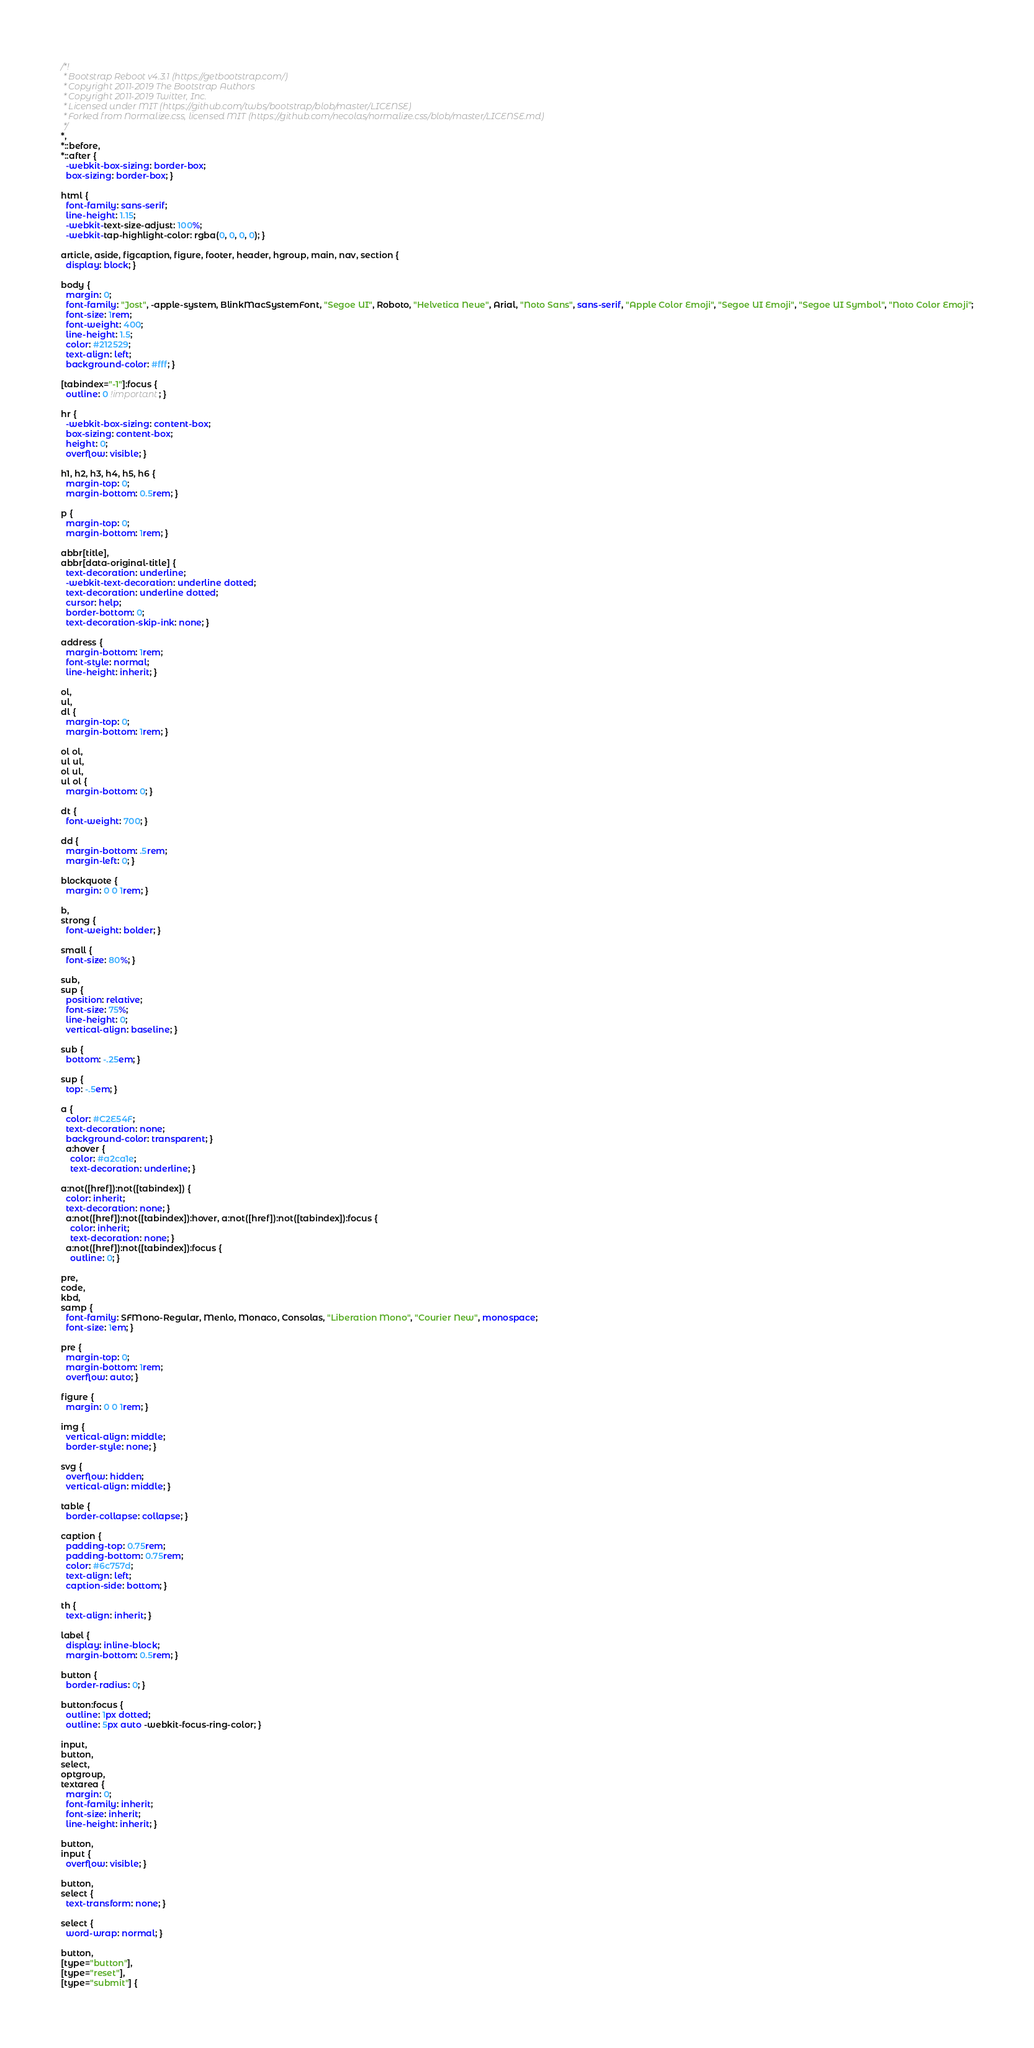<code> <loc_0><loc_0><loc_500><loc_500><_CSS_>/*!
 * Bootstrap Reboot v4.3.1 (https://getbootstrap.com/)
 * Copyright 2011-2019 The Bootstrap Authors
 * Copyright 2011-2019 Twitter, Inc.
 * Licensed under MIT (https://github.com/twbs/bootstrap/blob/master/LICENSE)
 * Forked from Normalize.css, licensed MIT (https://github.com/necolas/normalize.css/blob/master/LICENSE.md)
 */
*,
*::before,
*::after {
  -webkit-box-sizing: border-box;
  box-sizing: border-box; }

html {
  font-family: sans-serif;
  line-height: 1.15;
  -webkit-text-size-adjust: 100%;
  -webkit-tap-highlight-color: rgba(0, 0, 0, 0); }

article, aside, figcaption, figure, footer, header, hgroup, main, nav, section {
  display: block; }

body {
  margin: 0;
  font-family: "Jost", -apple-system, BlinkMacSystemFont, "Segoe UI", Roboto, "Helvetica Neue", Arial, "Noto Sans", sans-serif, "Apple Color Emoji", "Segoe UI Emoji", "Segoe UI Symbol", "Noto Color Emoji";
  font-size: 1rem;
  font-weight: 400;
  line-height: 1.5;
  color: #212529;
  text-align: left;
  background-color: #fff; }

[tabindex="-1"]:focus {
  outline: 0 !important; }

hr {
  -webkit-box-sizing: content-box;
  box-sizing: content-box;
  height: 0;
  overflow: visible; }

h1, h2, h3, h4, h5, h6 {
  margin-top: 0;
  margin-bottom: 0.5rem; }

p {
  margin-top: 0;
  margin-bottom: 1rem; }

abbr[title],
abbr[data-original-title] {
  text-decoration: underline;
  -webkit-text-decoration: underline dotted;
  text-decoration: underline dotted;
  cursor: help;
  border-bottom: 0;
  text-decoration-skip-ink: none; }

address {
  margin-bottom: 1rem;
  font-style: normal;
  line-height: inherit; }

ol,
ul,
dl {
  margin-top: 0;
  margin-bottom: 1rem; }

ol ol,
ul ul,
ol ul,
ul ol {
  margin-bottom: 0; }

dt {
  font-weight: 700; }

dd {
  margin-bottom: .5rem;
  margin-left: 0; }

blockquote {
  margin: 0 0 1rem; }

b,
strong {
  font-weight: bolder; }

small {
  font-size: 80%; }

sub,
sup {
  position: relative;
  font-size: 75%;
  line-height: 0;
  vertical-align: baseline; }

sub {
  bottom: -.25em; }

sup {
  top: -.5em; }

a {
  color: #C2E54F;
  text-decoration: none;
  background-color: transparent; }
  a:hover {
    color: #a2ca1e;
    text-decoration: underline; }

a:not([href]):not([tabindex]) {
  color: inherit;
  text-decoration: none; }
  a:not([href]):not([tabindex]):hover, a:not([href]):not([tabindex]):focus {
    color: inherit;
    text-decoration: none; }
  a:not([href]):not([tabindex]):focus {
    outline: 0; }

pre,
code,
kbd,
samp {
  font-family: SFMono-Regular, Menlo, Monaco, Consolas, "Liberation Mono", "Courier New", monospace;
  font-size: 1em; }

pre {
  margin-top: 0;
  margin-bottom: 1rem;
  overflow: auto; }

figure {
  margin: 0 0 1rem; }

img {
  vertical-align: middle;
  border-style: none; }

svg {
  overflow: hidden;
  vertical-align: middle; }

table {
  border-collapse: collapse; }

caption {
  padding-top: 0.75rem;
  padding-bottom: 0.75rem;
  color: #6c757d;
  text-align: left;
  caption-side: bottom; }

th {
  text-align: inherit; }

label {
  display: inline-block;
  margin-bottom: 0.5rem; }

button {
  border-radius: 0; }

button:focus {
  outline: 1px dotted;
  outline: 5px auto -webkit-focus-ring-color; }

input,
button,
select,
optgroup,
textarea {
  margin: 0;
  font-family: inherit;
  font-size: inherit;
  line-height: inherit; }

button,
input {
  overflow: visible; }

button,
select {
  text-transform: none; }

select {
  word-wrap: normal; }

button,
[type="button"],
[type="reset"],
[type="submit"] {</code> 